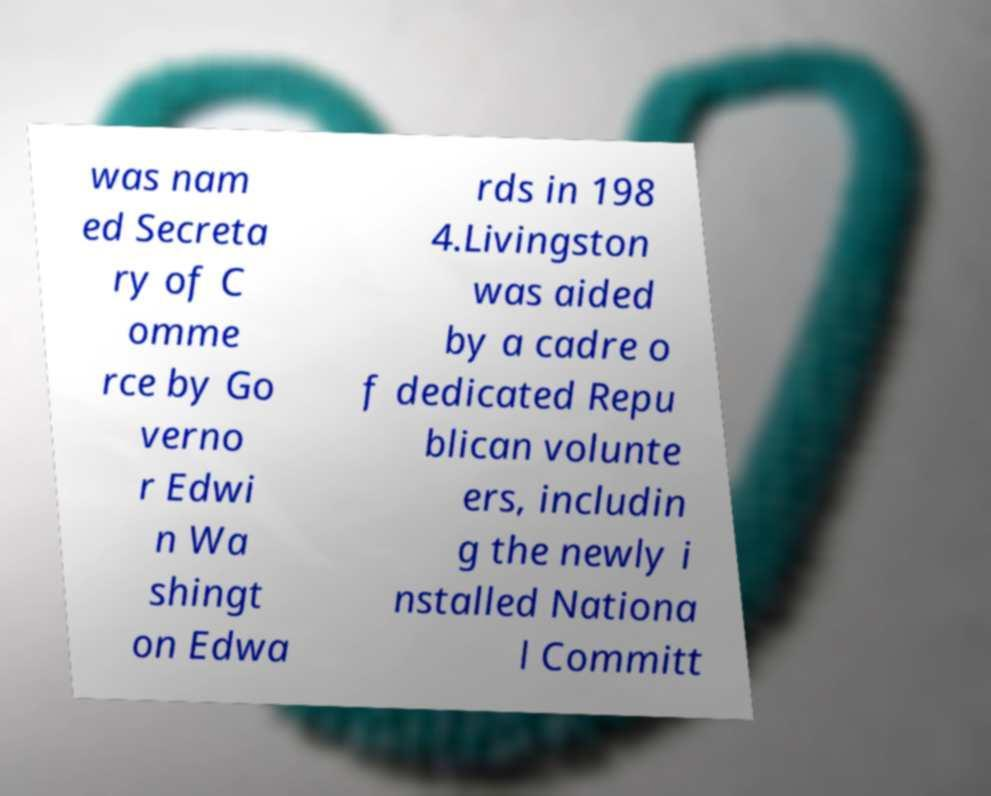What messages or text are displayed in this image? I need them in a readable, typed format. was nam ed Secreta ry of C omme rce by Go verno r Edwi n Wa shingt on Edwa rds in 198 4.Livingston was aided by a cadre o f dedicated Repu blican volunte ers, includin g the newly i nstalled Nationa l Committ 